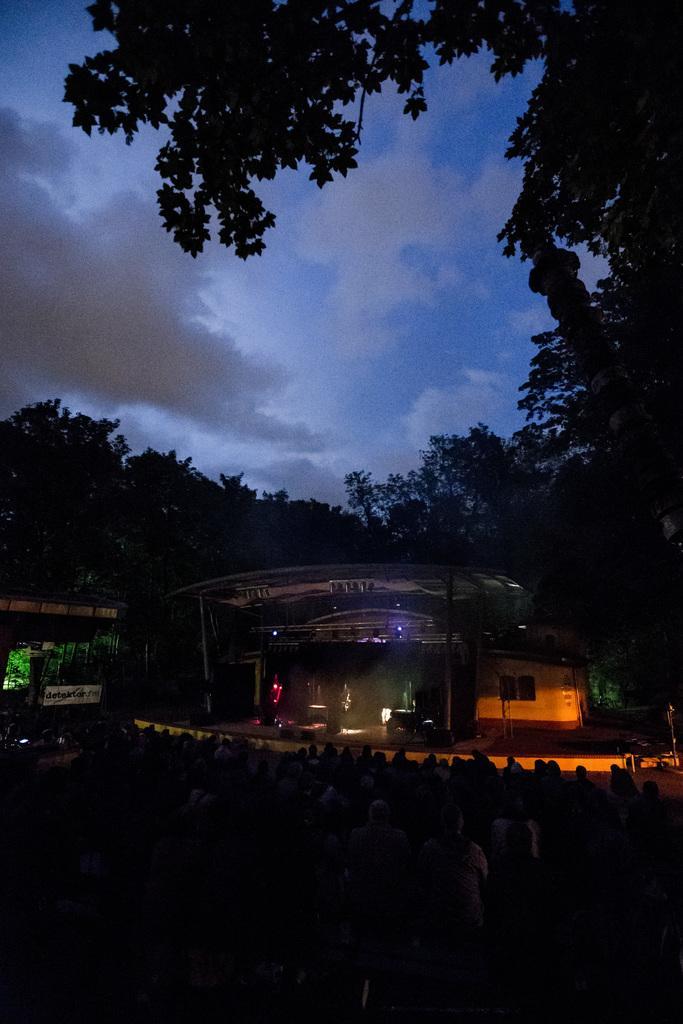How would you summarize this image in a sentence or two? In this picture I can see the shed, beside that I can see many trees, plants and grass. On the left I can see the sky and clouds. 